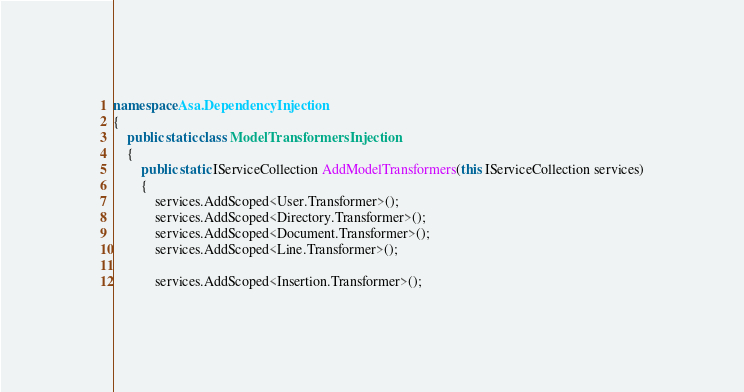Convert code to text. <code><loc_0><loc_0><loc_500><loc_500><_C#_>
namespace Asa.DependencyInjection
{
    public static class ModelTransformersInjection
    {
        public static IServiceCollection AddModelTransformers(this IServiceCollection services)
        {
            services.AddScoped<User.Transformer>();
            services.AddScoped<Directory.Transformer>();
            services.AddScoped<Document.Transformer>();
            services.AddScoped<Line.Transformer>();

            services.AddScoped<Insertion.Transformer>();</code> 